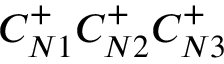Convert formula to latex. <formula><loc_0><loc_0><loc_500><loc_500>C _ { N 1 } ^ { + } C _ { N 2 } ^ { + } C _ { N 3 } ^ { + }</formula> 